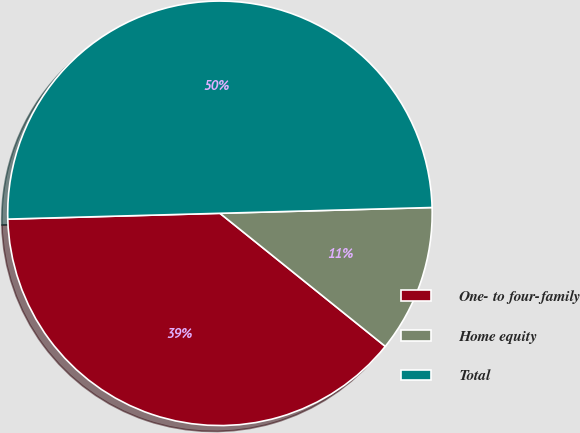<chart> <loc_0><loc_0><loc_500><loc_500><pie_chart><fcel>One- to four-family<fcel>Home equity<fcel>Total<nl><fcel>38.78%<fcel>11.22%<fcel>50.0%<nl></chart> 